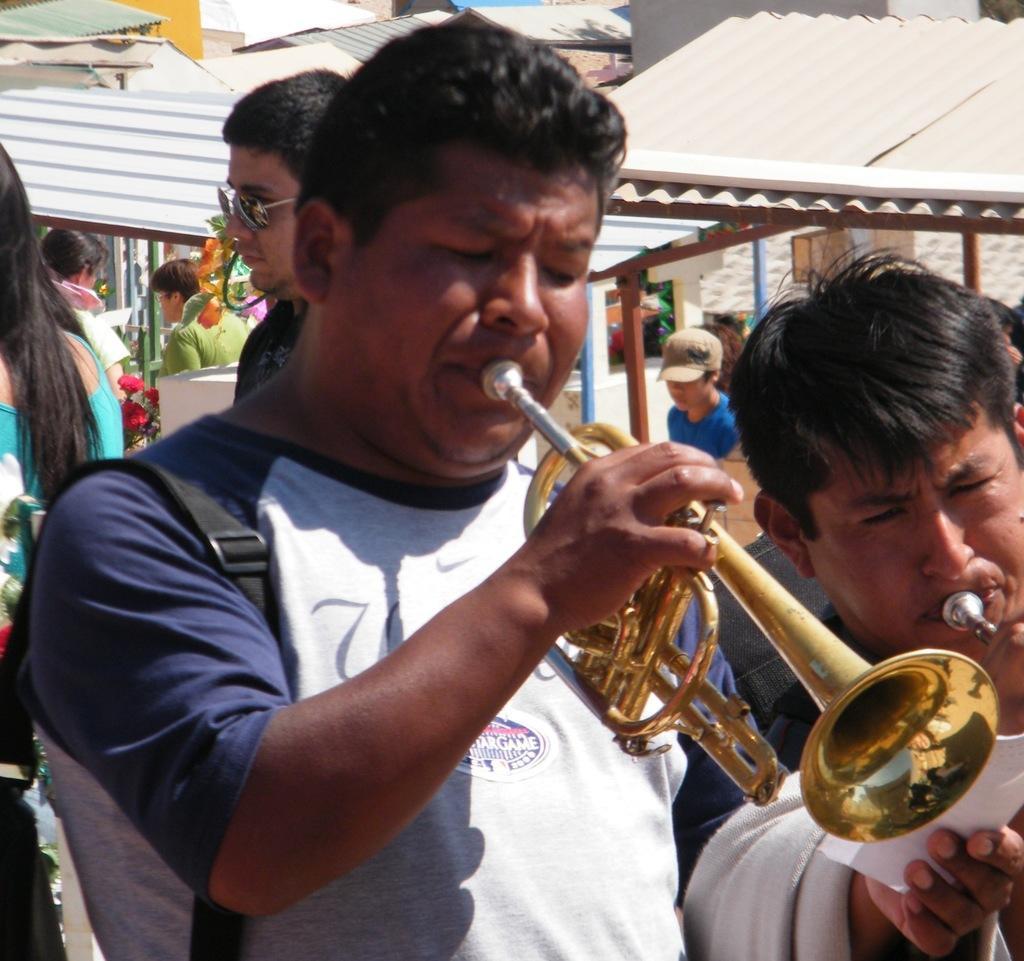Can you describe this image briefly? In this image I can see the group of people with different color dresses. I can see two people are are playing the trumpet. In the background I can see the shed. I can also see the person wearing the cap. 